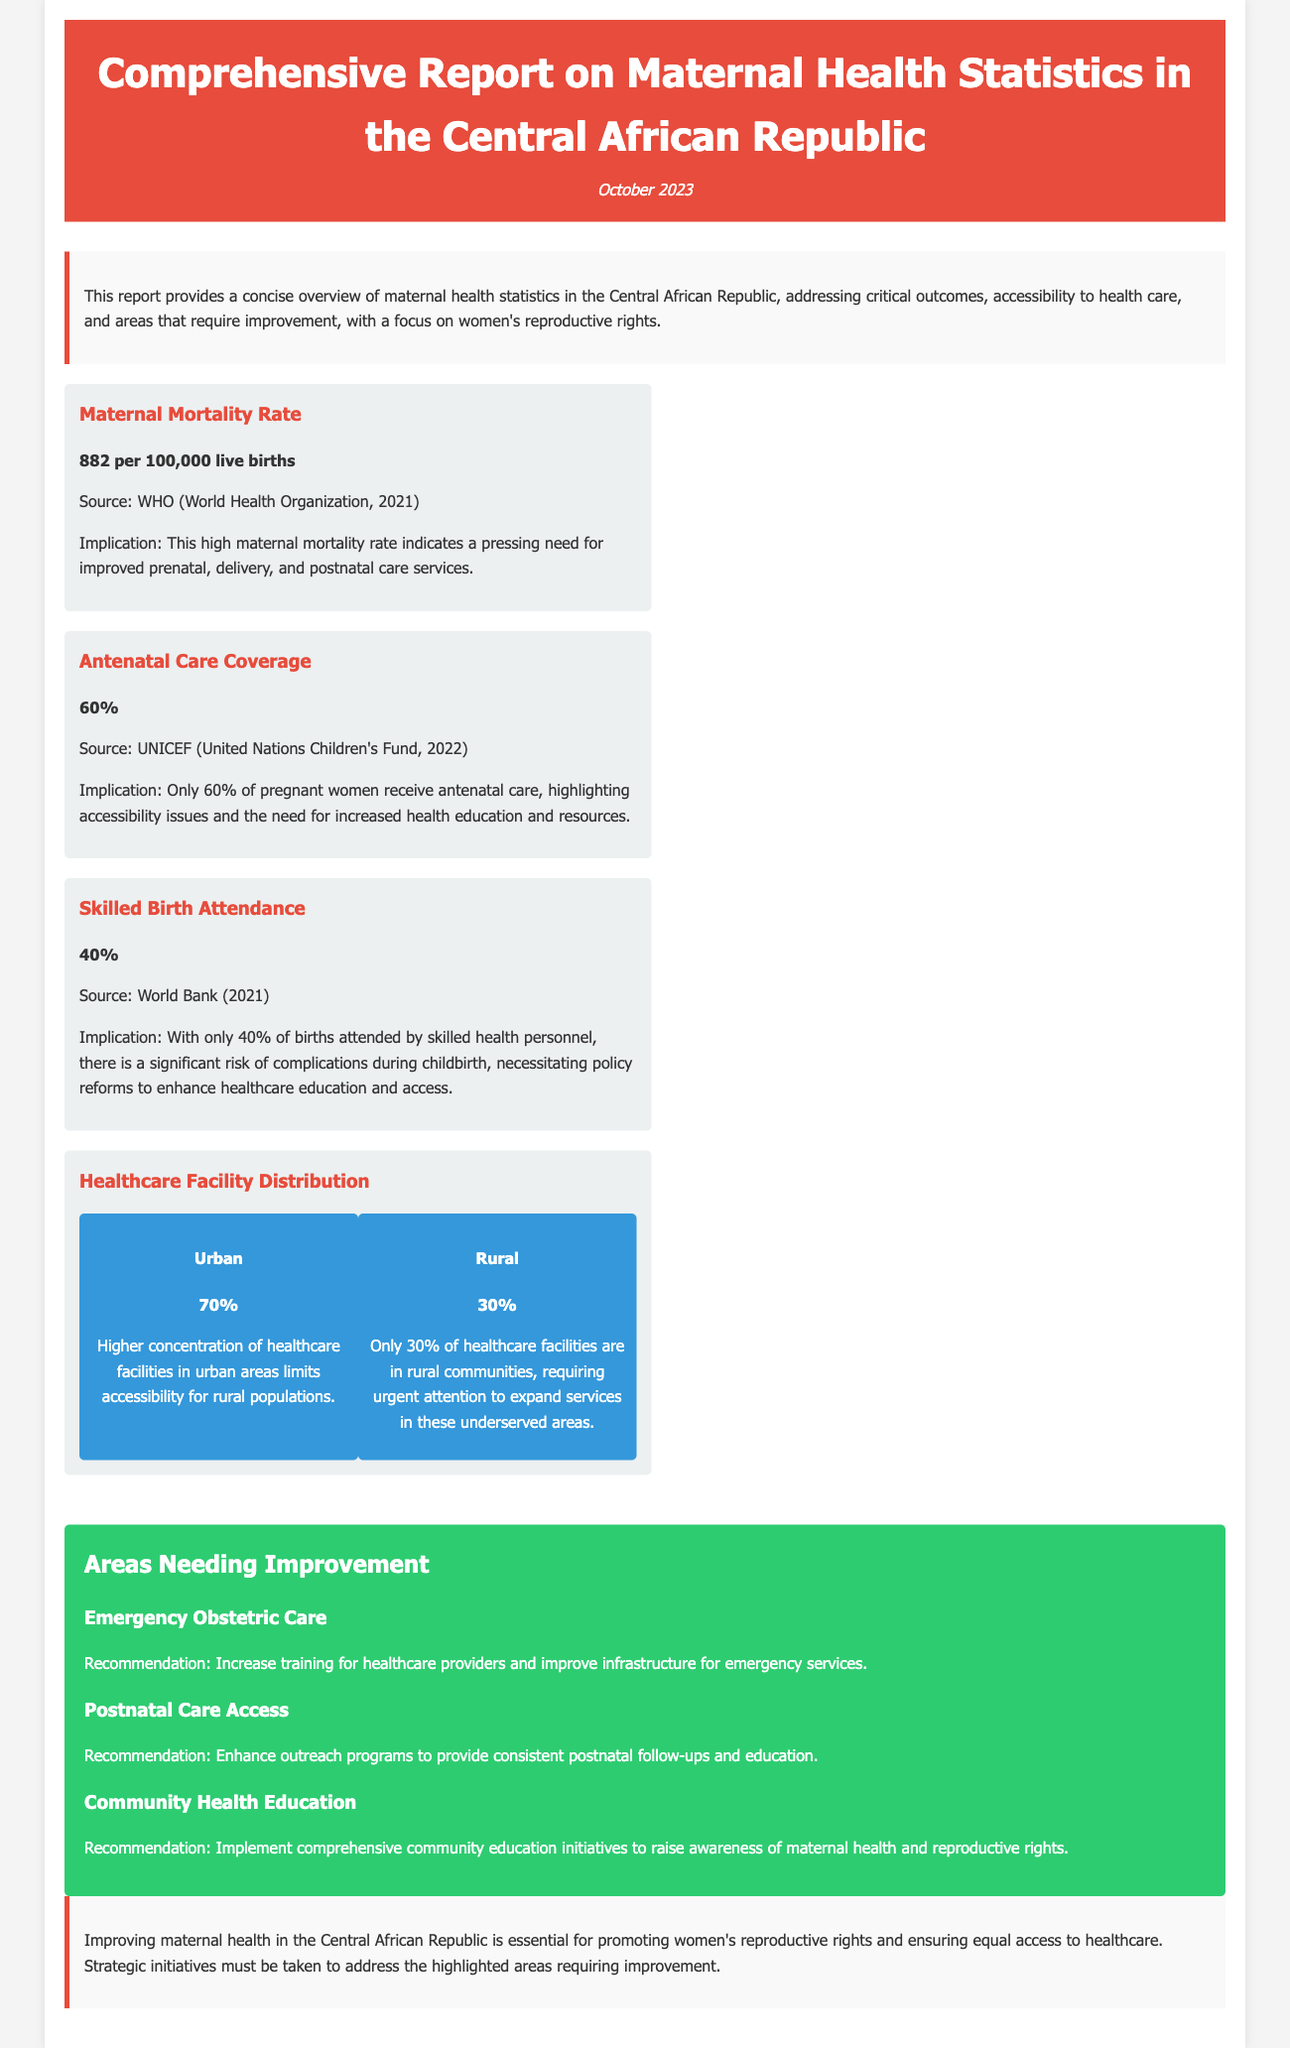What is the maternal mortality rate? The maternal mortality rate is a critical figure outlined in the report, indicating health outcomes for women during childbirth.
Answer: 882 per 100,000 live births What percentage of pregnant women receive antenatal care? The report specifies the proportion of pregnant women who get antenatal care, reflecting accessibility issues.
Answer: 60% What is the percentage of skilled birth attendance? This percentage reflects how many births are attended by skilled healthcare personnel, highlighting potential risks.
Answer: 40% What is the distribution of healthcare facilities in urban areas? The report provides specific figures about the concentration of healthcare facilities in urban regions compared to rural areas.
Answer: 70% What is the recommendation for improving emergency obstetric care? The report identifies specific recommendations to enhance maternal healthcare services, which includes addressing emergency cases.
Answer: Increase training for healthcare providers and improve infrastructure for emergency services What area needs enhanced outreach programs? The report outlines specific areas requiring intervention to assist new mothers and improve outcomes.
Answer: Postnatal Care Access What does the report emphasize about community health education? The report provides practical recommendations that pertain to raising awareness around maternal health issues.
Answer: Implement comprehensive community education initiatives to raise awareness of maternal health and reproductive rights What is the implications of the high maternal mortality rate? The report explains the concerns related to maternal mortality, particularly regarding care services provided.
Answer: Indicates a pressing need for improved prenatal, delivery, and postnatal care services What is the publication date of the report? The date is mentioned at the beginning of the document, indicating when the information was compiled.
Answer: October 2023 